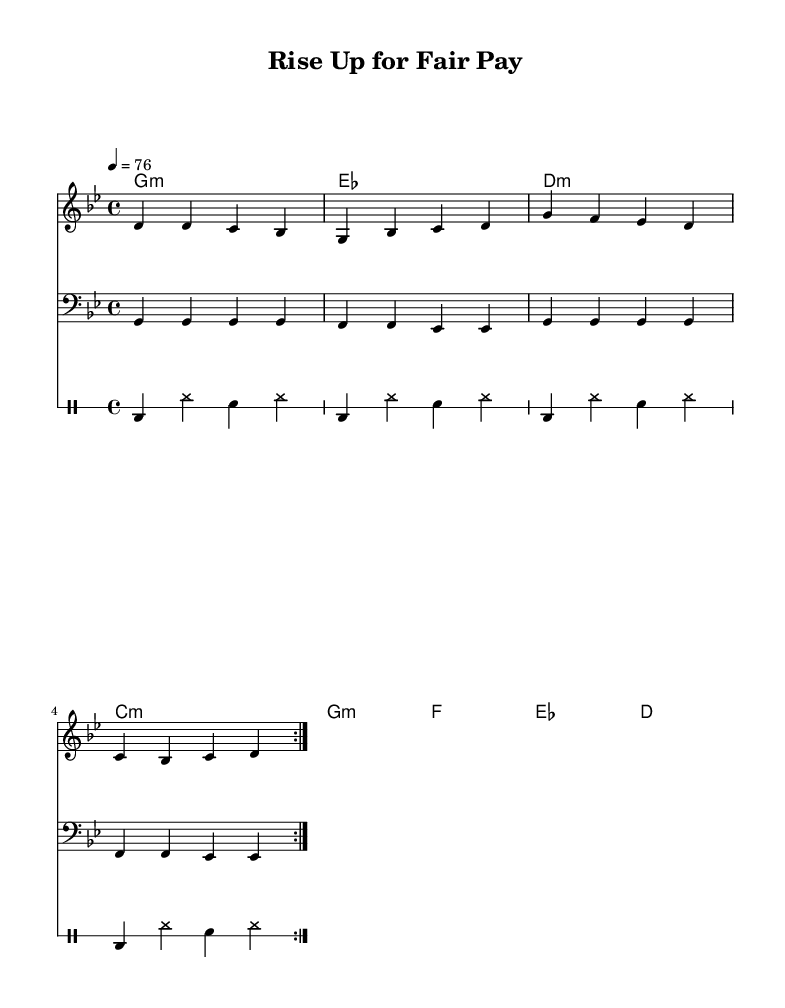What is the key signature of this music? The key signature is represented by the presence of two flats (B♭ and E♭), indicating that the piece is in G minor.
Answer: G minor What is the time signature of this music? The time signature is indicated at the beginning of the piece, showing a 4/4 pattern, meaning there are four beats in each measure.
Answer: 4/4 What is the tempo marking of this music? The tempo marking is set at 76 beats per minute, which guides the speed of the performance.
Answer: 76 How many measures are repeated in this piece? The repetition is indicated by the "volta" markings, which state that the section is repeated twice throughout the piece.
Answer: 2 What instrument plays the melody? The melody is notated in a separate staff labeled "melody," indicating that it is intended for a lead instrument, likely a voice or guitar.
Answer: Melody What lyrical theme is expressed in the chorus? The chorus emphasizes the idea of rising up and standing strong for living wages, which is highlighted in the lyrics provided.
Answer: Living wages How does the rhythm contribute to the reggae style? The drum pattern with bass drum (bd), hi-hat (hh), and snare (sn) creates a characteristic offbeat rhythm that is fundamental to reggae music.
Answer: Offbeat rhythm 